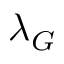Convert formula to latex. <formula><loc_0><loc_0><loc_500><loc_500>\lambda _ { G }</formula> 